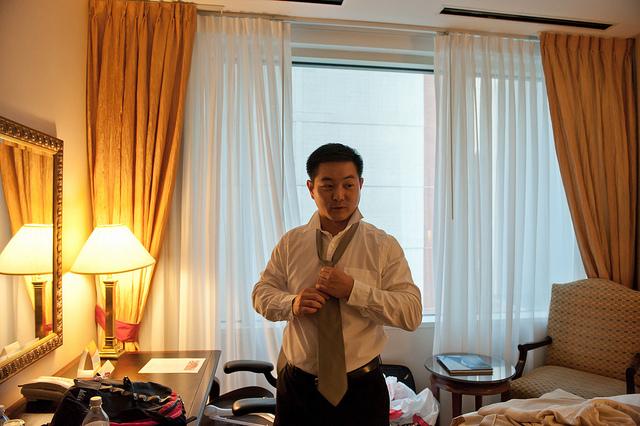What race is the man?
Keep it brief. Asian. Is the light on?
Give a very brief answer. Yes. Is he in a hotel room?
Answer briefly. Yes. 